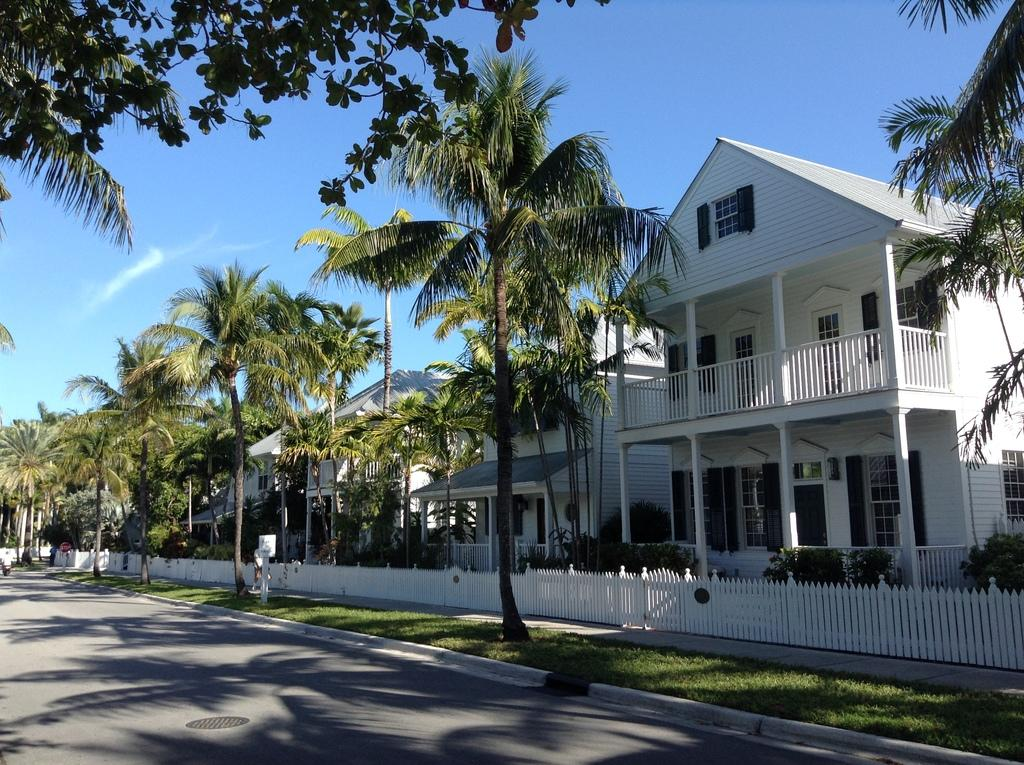What is located in the center of the image? There are buildings in the center of the image. What type of vegetation can be seen in the image? There are trees in the image. What is the purpose of the barrier in the image? There is a fence in the image, which serves as a barrier. Can you describe the objects in the image? There are objects in the image, but their specific nature is not mentioned in the provided facts. What is at the bottom of the image? There is a road and grass at the bottom of the image. What is visible at the top of the image? The sky is visible at the top of the image. What is the latest news about the baseball game in the image? There is no mention of a baseball game or any news in the image or the provided facts. 